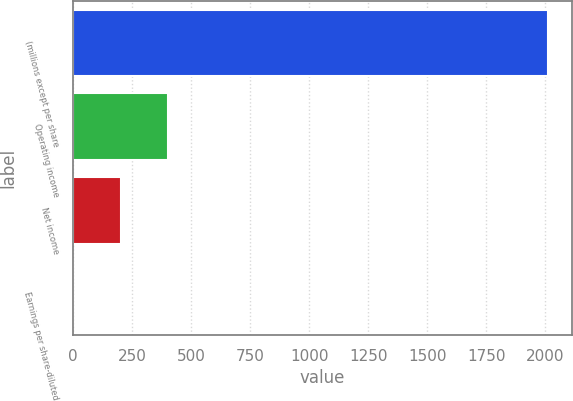<chart> <loc_0><loc_0><loc_500><loc_500><bar_chart><fcel>(millions except per share<fcel>Operating income<fcel>Net income<fcel>Earnings per share-diluted<nl><fcel>2013<fcel>402.78<fcel>201.5<fcel>0.22<nl></chart> 